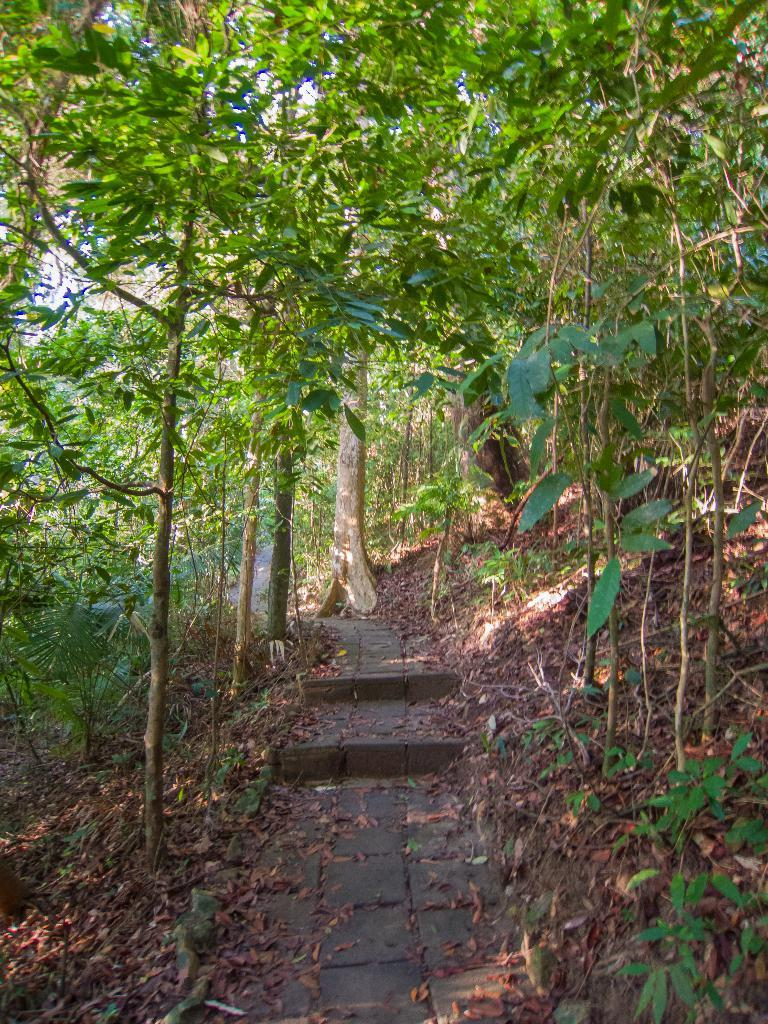What type of vegetation can be seen in the image? There are trees and plants in the image. What part of the trees can be seen in the image? Leaves are present in the image. What is visible in the background of the image? The sky is visible in the image. How many light bulbs can be seen hanging from the trees in the image? There are no light bulbs present in the image; it features trees, plants, leaves, and the sky. What sense is being stimulated by the plants in the image? The image does not provide information about which sense is being stimulated by the plants. 